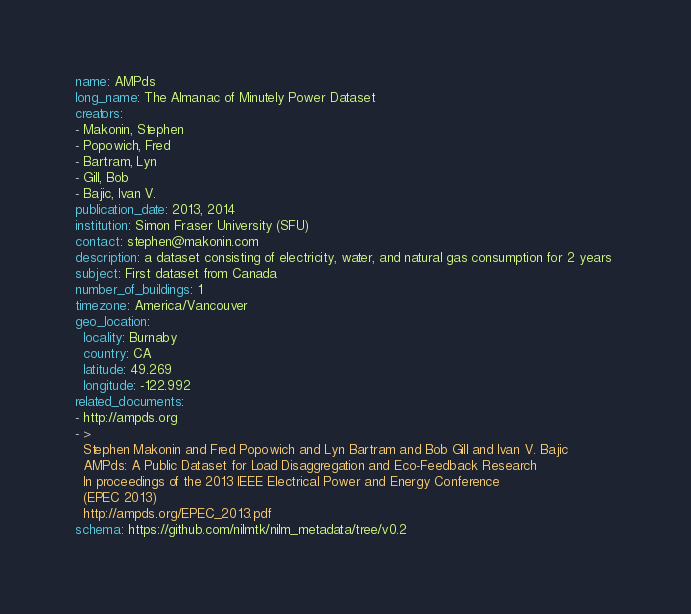Convert code to text. <code><loc_0><loc_0><loc_500><loc_500><_YAML_>name: AMPds
long_name: The Almanac of Minutely Power Dataset
creators:
- Makonin, Stephen
- Popowich, Fred
- Bartram, Lyn
- Gill, Bob
- Bajic, Ivan V.
publication_date: 2013, 2014
institution: Simon Fraser University (SFU)
contact: stephen@makonin.com
description: a dataset consisting of electricity, water, and natural gas consumption for 2 years 
subject: First dataset from Canada
number_of_buildings: 1
timezone: America/Vancouver
geo_location:
  locality: Burnaby
  country: CA
  latitude: 49.269
  longitude: -122.992
related_documents:
- http://ampds.org
- >
  Stephen Makonin and Fred Popowich and Lyn Bartram and Bob Gill and Ivan V. Bajic
  AMPds: A Public Dataset for Load Disaggregation and Eco-Feedback Research
  In proceedings of the 2013 IEEE Electrical Power and Energy Conference 
  (EPEC 2013)
  http://ampds.org/EPEC_2013.pdf
schema: https://github.com/nilmtk/nilm_metadata/tree/v0.2
</code> 